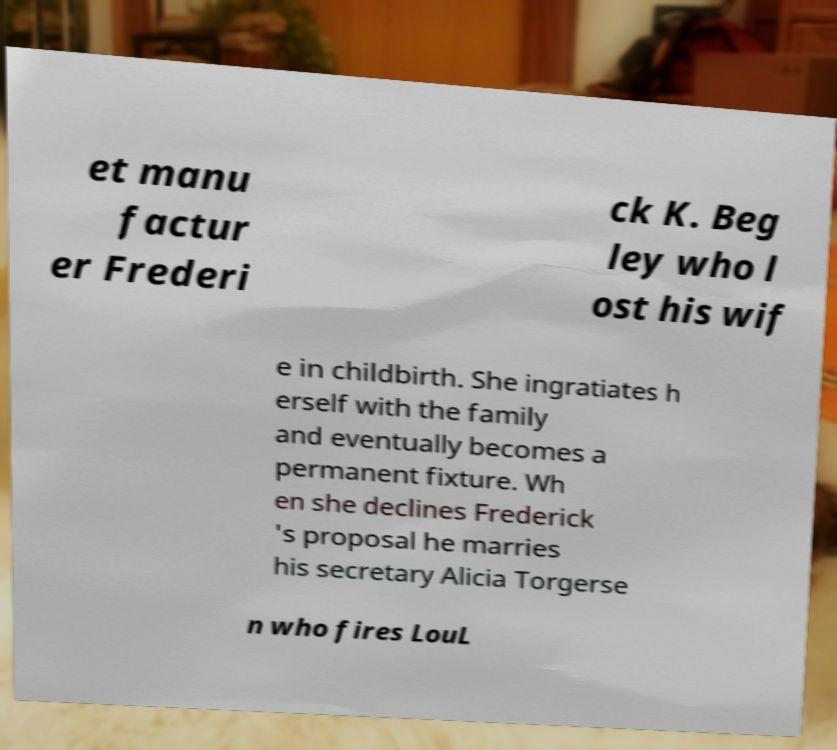Can you read and provide the text displayed in the image?This photo seems to have some interesting text. Can you extract and type it out for me? et manu factur er Frederi ck K. Beg ley who l ost his wif e in childbirth. She ingratiates h erself with the family and eventually becomes a permanent fixture. Wh en she declines Frederick 's proposal he marries his secretary Alicia Torgerse n who fires LouL 